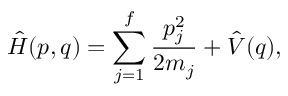Convert formula to latex. <formula><loc_0><loc_0><loc_500><loc_500>\hat { H } ( p , q ) = \sum _ { j = 1 } ^ { f } \frac { p _ { j } ^ { 2 } } { 2 m _ { j } } + \hat { V } ( q ) ,</formula> 